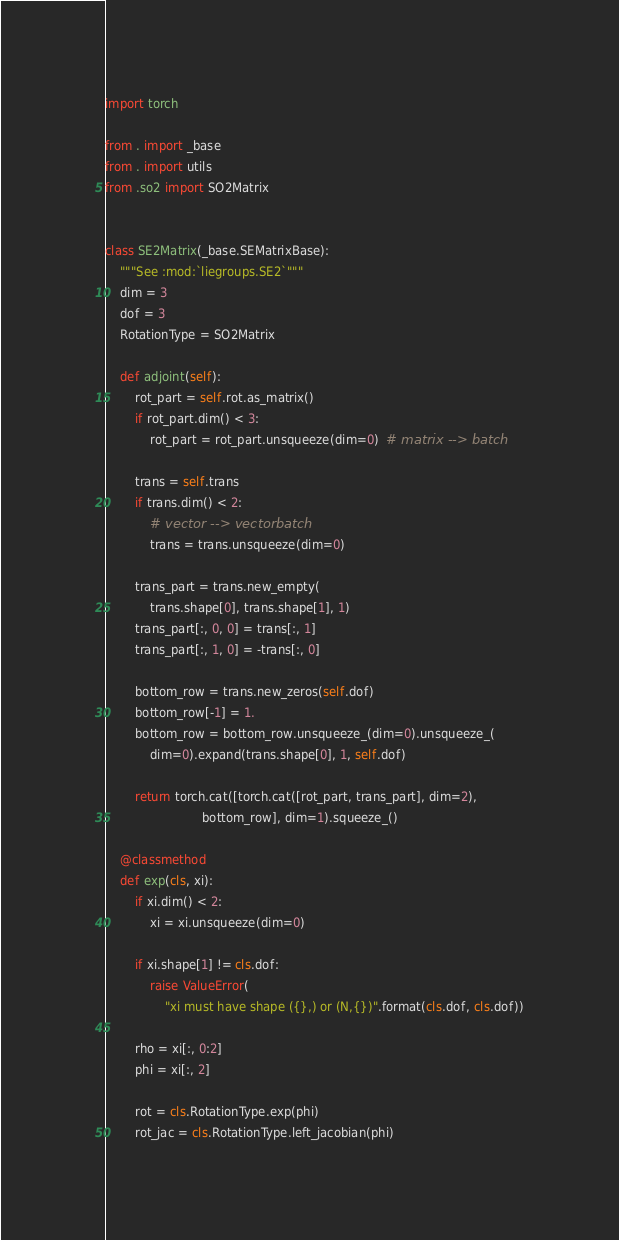Convert code to text. <code><loc_0><loc_0><loc_500><loc_500><_Python_>import torch

from . import _base
from . import utils
from .so2 import SO2Matrix


class SE2Matrix(_base.SEMatrixBase):
    """See :mod:`liegroups.SE2`"""
    dim = 3
    dof = 3
    RotationType = SO2Matrix

    def adjoint(self):
        rot_part = self.rot.as_matrix()
        if rot_part.dim() < 3:
            rot_part = rot_part.unsqueeze(dim=0)  # matrix --> batch

        trans = self.trans
        if trans.dim() < 2:
            # vector --> vectorbatch
            trans = trans.unsqueeze(dim=0)

        trans_part = trans.new_empty(
            trans.shape[0], trans.shape[1], 1)
        trans_part[:, 0, 0] = trans[:, 1]
        trans_part[:, 1, 0] = -trans[:, 0]

        bottom_row = trans.new_zeros(self.dof)
        bottom_row[-1] = 1.
        bottom_row = bottom_row.unsqueeze_(dim=0).unsqueeze_(
            dim=0).expand(trans.shape[0], 1, self.dof)

        return torch.cat([torch.cat([rot_part, trans_part], dim=2),
                          bottom_row], dim=1).squeeze_()

    @classmethod
    def exp(cls, xi):
        if xi.dim() < 2:
            xi = xi.unsqueeze(dim=0)

        if xi.shape[1] != cls.dof:
            raise ValueError(
                "xi must have shape ({},) or (N,{})".format(cls.dof, cls.dof))

        rho = xi[:, 0:2]
        phi = xi[:, 2]

        rot = cls.RotationType.exp(phi)
        rot_jac = cls.RotationType.left_jacobian(phi)
</code> 